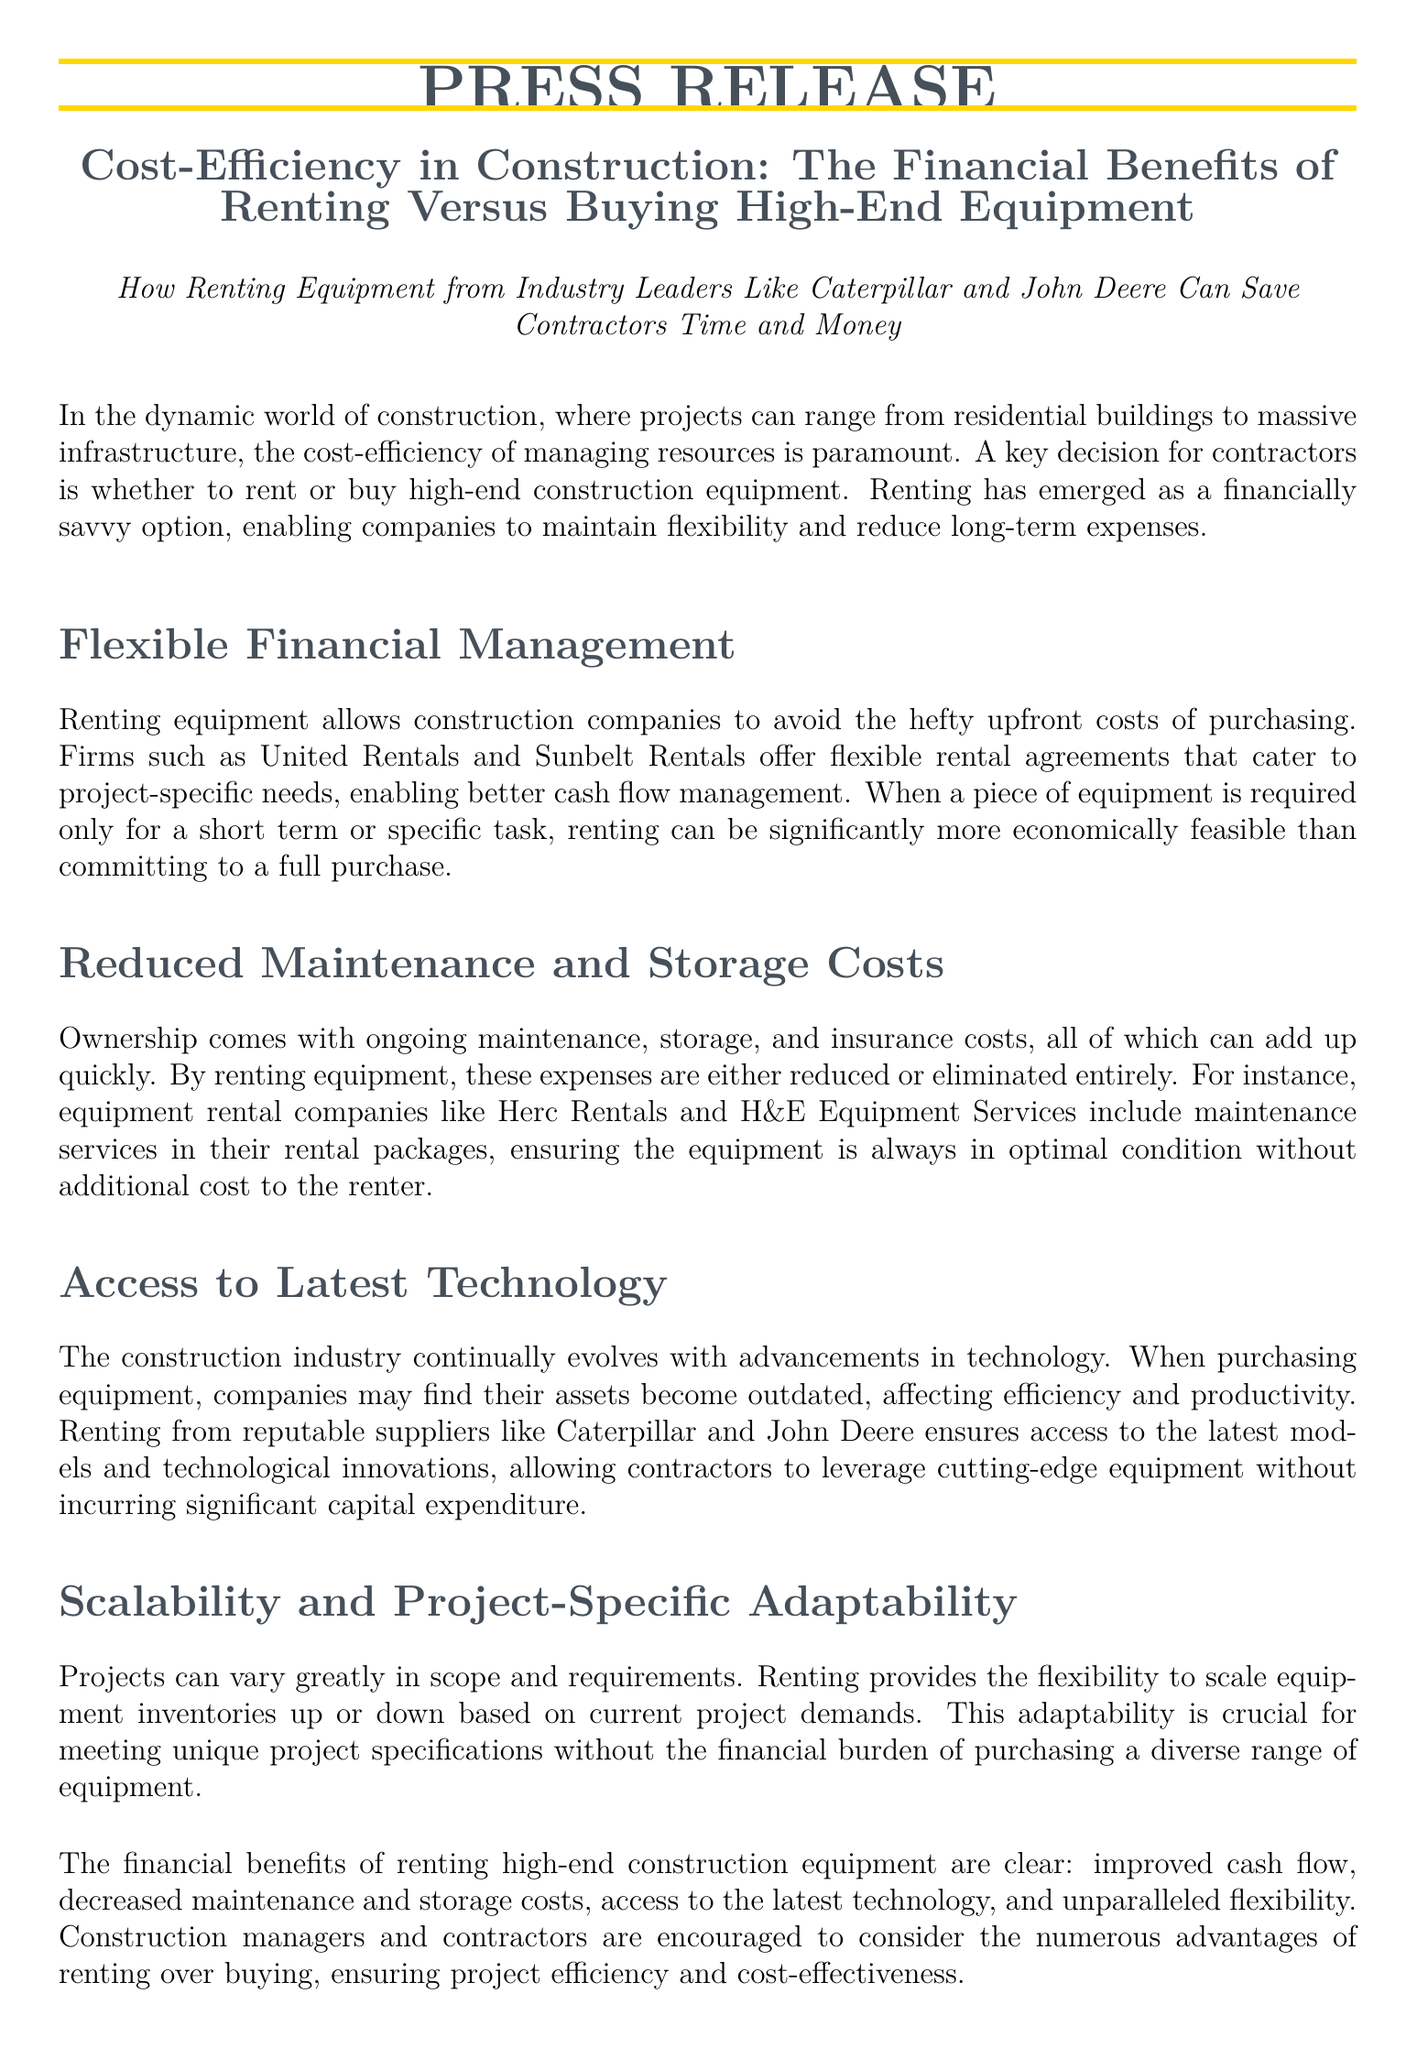What is the title of the press release? The title summarizes the main topic of the document, which discusses the financial advantages of renting equipment.
Answer: Cost-Efficiency in Construction: The Financial Benefits of Renting Versus Buying High-End Equipment Who are two suppliers mentioned for renting equipment? The press release highlights reputable suppliers in the equipment rental industry.
Answer: Caterpillar and John Deere What financial aspect does renting equipment help improve? The text discusses the financial benefits of renting equipment, particularly in managing expenses.
Answer: Cash flow What costs are reduced or eliminated by renting equipment? Renting equipment alleviates certain costs associated with ownership, according to the document.
Answer: Maintenance and storage costs How does renting equipment affect technology access? The press release explains that renting allows companies to utilize the latest advancements without a significant capital expenditure.
Answer: Access to the latest technology What flexibility does renting provide for construction projects? The document states that renting allows adjustments based on varying project requirements and demands.
Answer: Scalability and project-specific adaptability What is the name of the company for further inquiries? The press release provides contact information for readers seeking more details about equipment rental.
Answer: Precision Rentals Inc Who is the contact person listed in the press release? The contact information section identifies an individual for inquiries about the rental company.
Answer: John Doe 